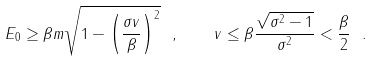<formula> <loc_0><loc_0><loc_500><loc_500>E _ { 0 } \geq \beta m \sqrt { 1 - \left ( \frac { \sigma v } { \beta } \right ) ^ { 2 } } \ , \quad v \leq \beta \frac { \sqrt { \sigma ^ { 2 } - 1 } } { \sigma ^ { 2 } } < \frac { \beta } { 2 } \ .</formula> 